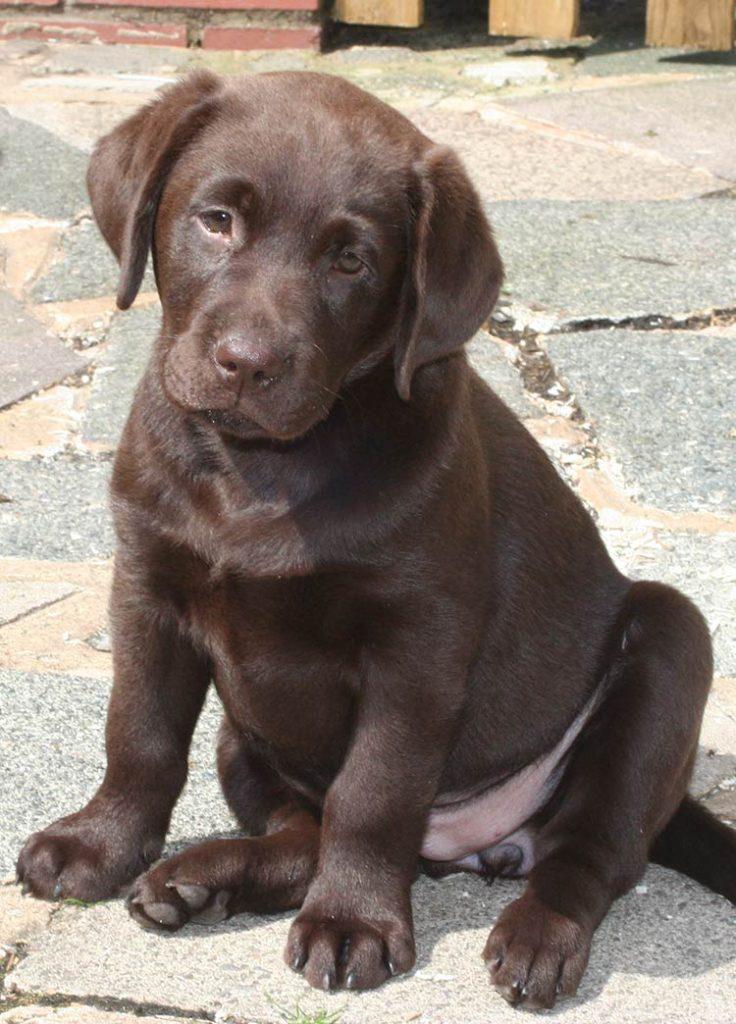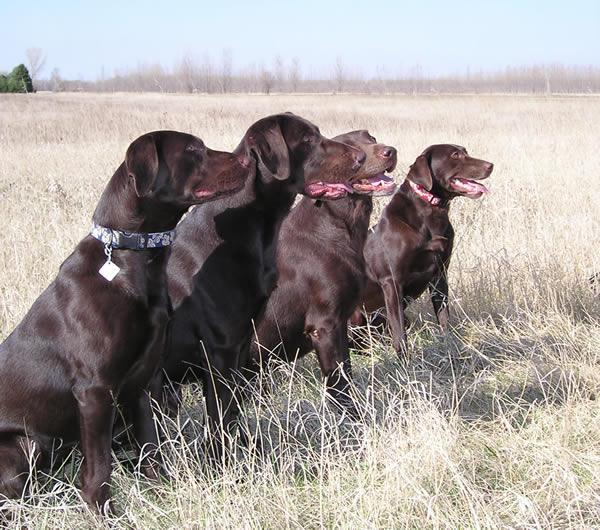The first image is the image on the left, the second image is the image on the right. For the images displayed, is the sentence "All of the dogs are sitting." factually correct? Answer yes or no. Yes. 